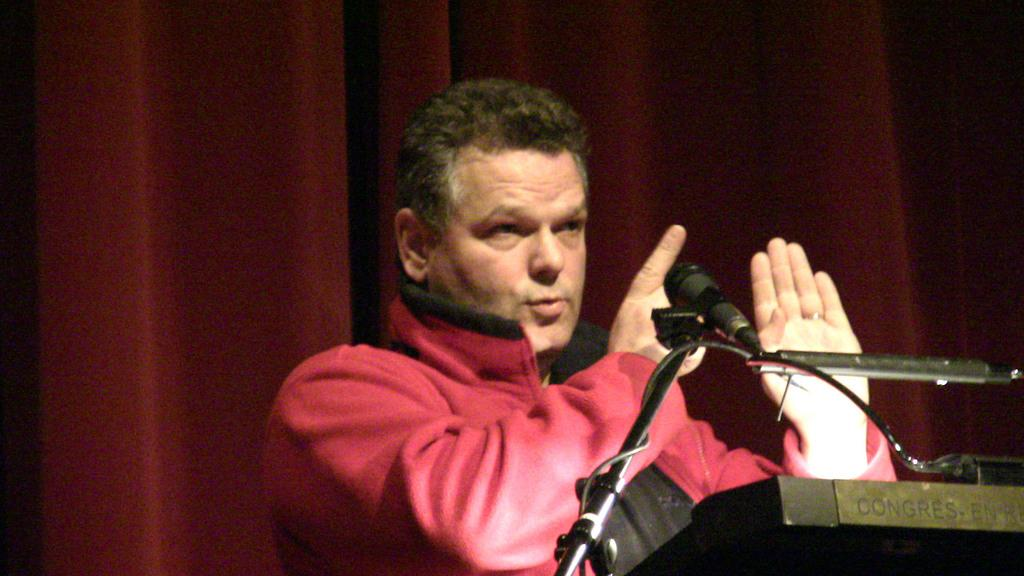What is the person near in the image? There is a person standing near the podium in the image. What can be seen on the podium? There is a microphone on a stand on the podium. ium. What type of building can be seen in the background of the image? There is no building visible in the image; it only shows a person standing near a podium with a microphone on a stand. 